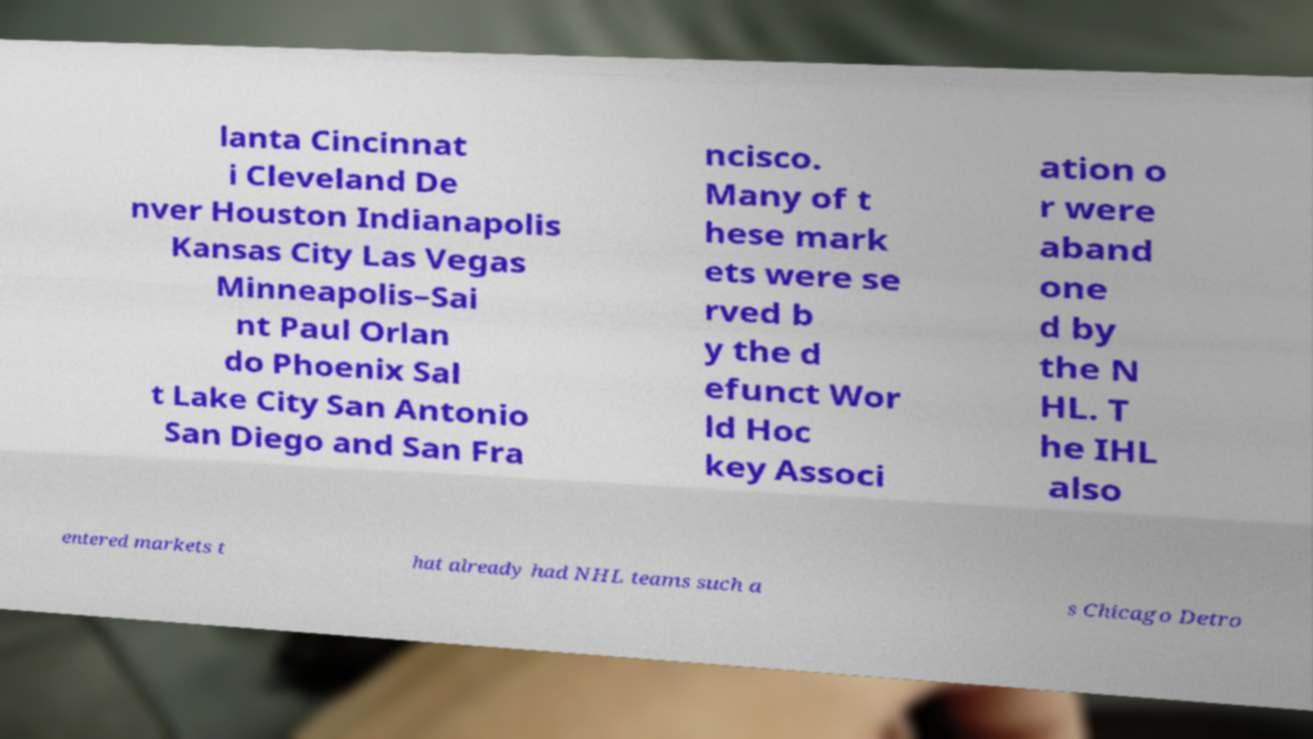What messages or text are displayed in this image? I need them in a readable, typed format. lanta Cincinnat i Cleveland De nver Houston Indianapolis Kansas City Las Vegas Minneapolis–Sai nt Paul Orlan do Phoenix Sal t Lake City San Antonio San Diego and San Fra ncisco. Many of t hese mark ets were se rved b y the d efunct Wor ld Hoc key Associ ation o r were aband one d by the N HL. T he IHL also entered markets t hat already had NHL teams such a s Chicago Detro 